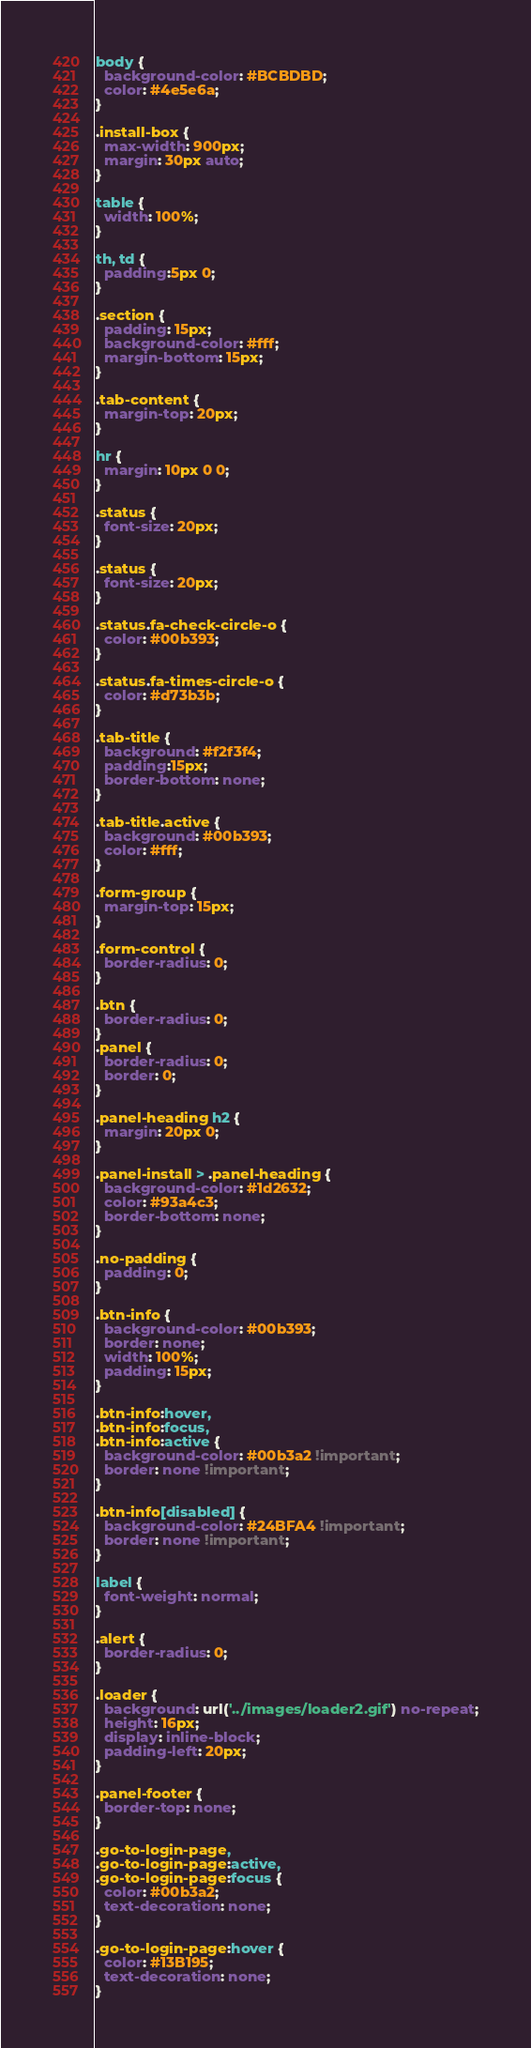<code> <loc_0><loc_0><loc_500><loc_500><_CSS_>body {
  background-color: #BCBDBD;
  color: #4e5e6a;
}

.install-box {
  max-width: 900px;
  margin: 30px auto;
}

table {
  width: 100%;
}

th, td {
  padding:5px 0;
}

.section {
  padding: 15px;
  background-color: #fff;
  margin-bottom: 15px;
}

.tab-content {
  margin-top: 20px;
}

hr {
  margin: 10px 0 0;
}

.status {
  font-size: 20px;
}

.status {
  font-size: 20px;
}

.status.fa-check-circle-o {
  color: #00b393;
}

.status.fa-times-circle-o {
  color: #d73b3b;
}

.tab-title {
  background: #f2f3f4;
  padding:15px;
  border-bottom: none;
}

.tab-title.active {
  background: #00b393;
  color: #fff;
}

.form-group {
  margin-top: 15px;
}

.form-control {
  border-radius: 0;
}

.btn {
  border-radius: 0;
}
.panel {
  border-radius: 0;
  border: 0;
}

.panel-heading h2 {
  margin: 20px 0;
}

.panel-install > .panel-heading {
  background-color: #1d2632;
  color: #93a4c3;
  border-bottom: none;
}

.no-padding {
  padding: 0;
}

.btn-info {
  background-color: #00b393;
  border: none;
  width: 100%;
  padding: 15px;
}

.btn-info:hover,
.btn-info:focus,
.btn-info:active {
  background-color: #00b3a2 !important;
  border: none !important;
}

.btn-info[disabled] {
  background-color: #24BFA4 !important;
  border: none !important;
}

label {
  font-weight: normal;
}

.alert {
  border-radius: 0;
}

.loader {
  background: url('../images/loader2.gif') no-repeat;
  height: 16px;
  display: inline-block;
  padding-left: 20px;
}

.panel-footer {
  border-top: none;
}

.go-to-login-page,
.go-to-login-page:active,
.go-to-login-page:focus {
  color: #00b3a2;
  text-decoration: none;
}

.go-to-login-page:hover {
  color: #13B195;
  text-decoration: none;
}
</code> 